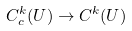Convert formula to latex. <formula><loc_0><loc_0><loc_500><loc_500>C _ { c } ^ { k } ( U ) \to C ^ { k } ( U )</formula> 